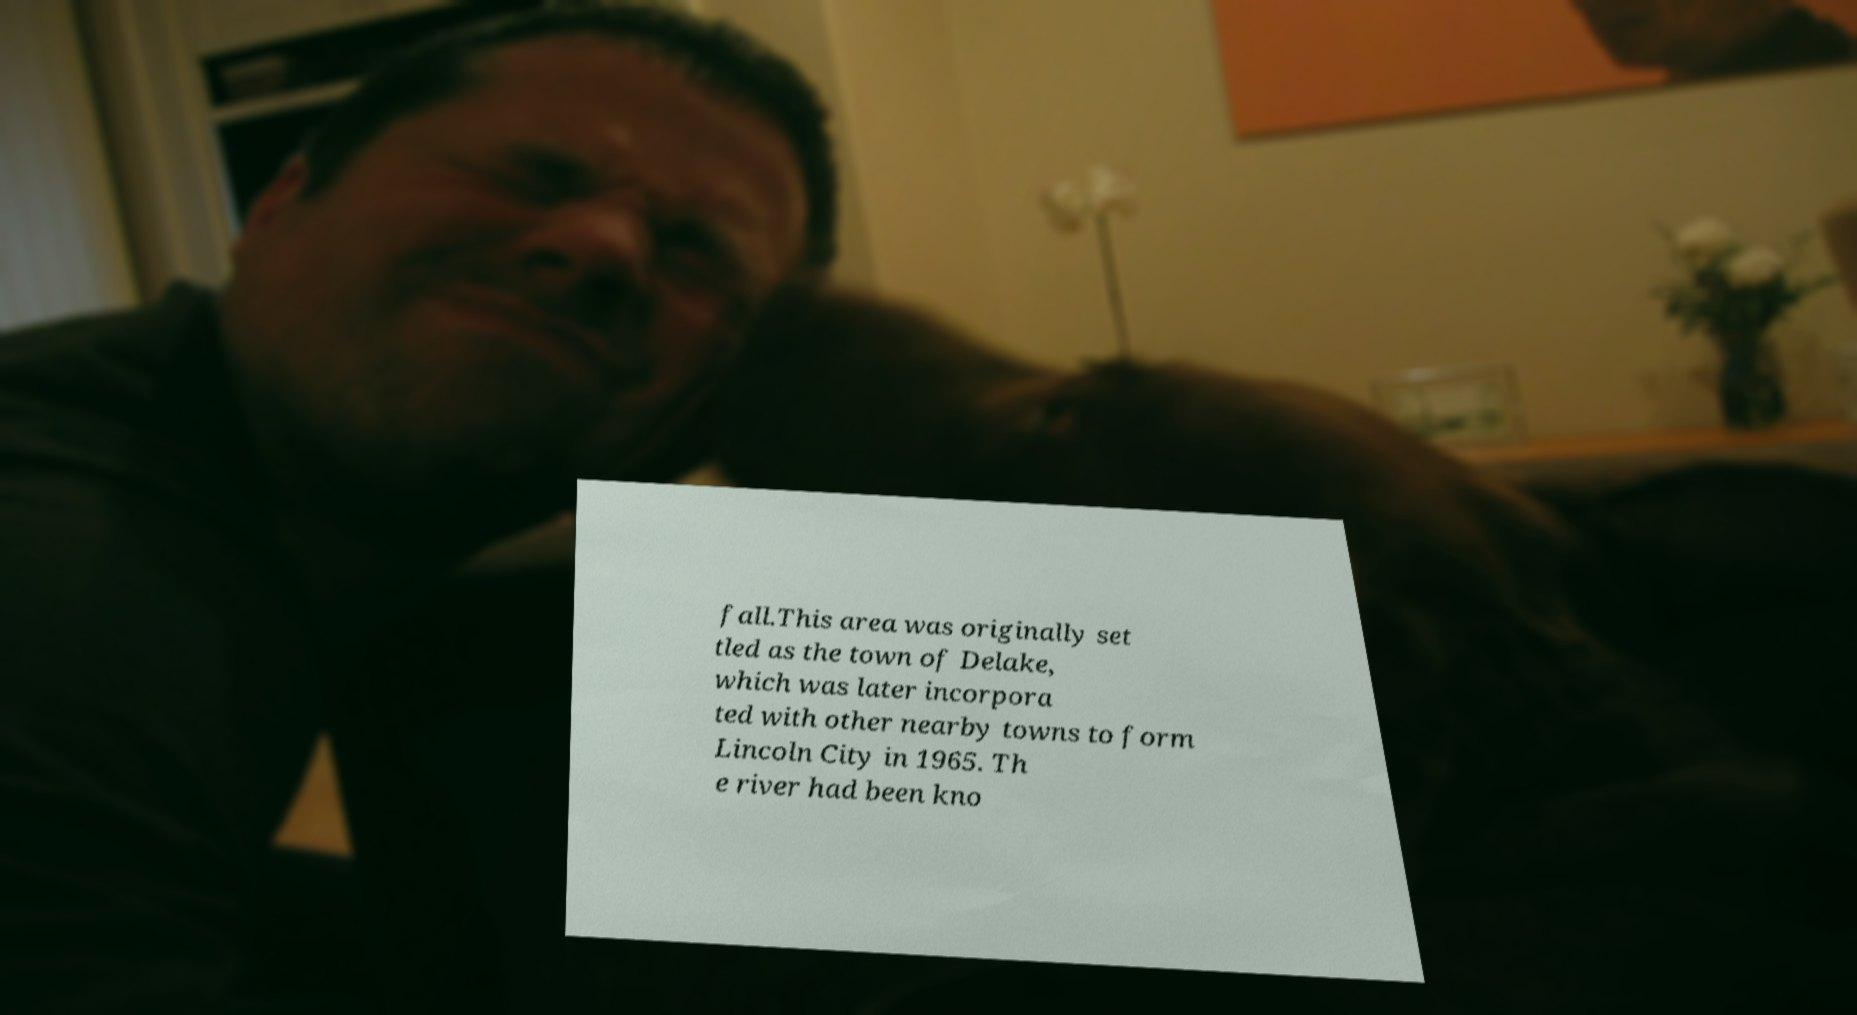Please read and relay the text visible in this image. What does it say? fall.This area was originally set tled as the town of Delake, which was later incorpora ted with other nearby towns to form Lincoln City in 1965. Th e river had been kno 